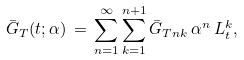<formula> <loc_0><loc_0><loc_500><loc_500>\bar { G } _ { T } ( t ; \alpha ) \, = \, \sum _ { n = 1 } ^ { \infty } \sum _ { k = 1 } ^ { n + 1 } \bar { G } _ { T n k } \, \alpha ^ { n } \, L _ { t } ^ { k } ,</formula> 